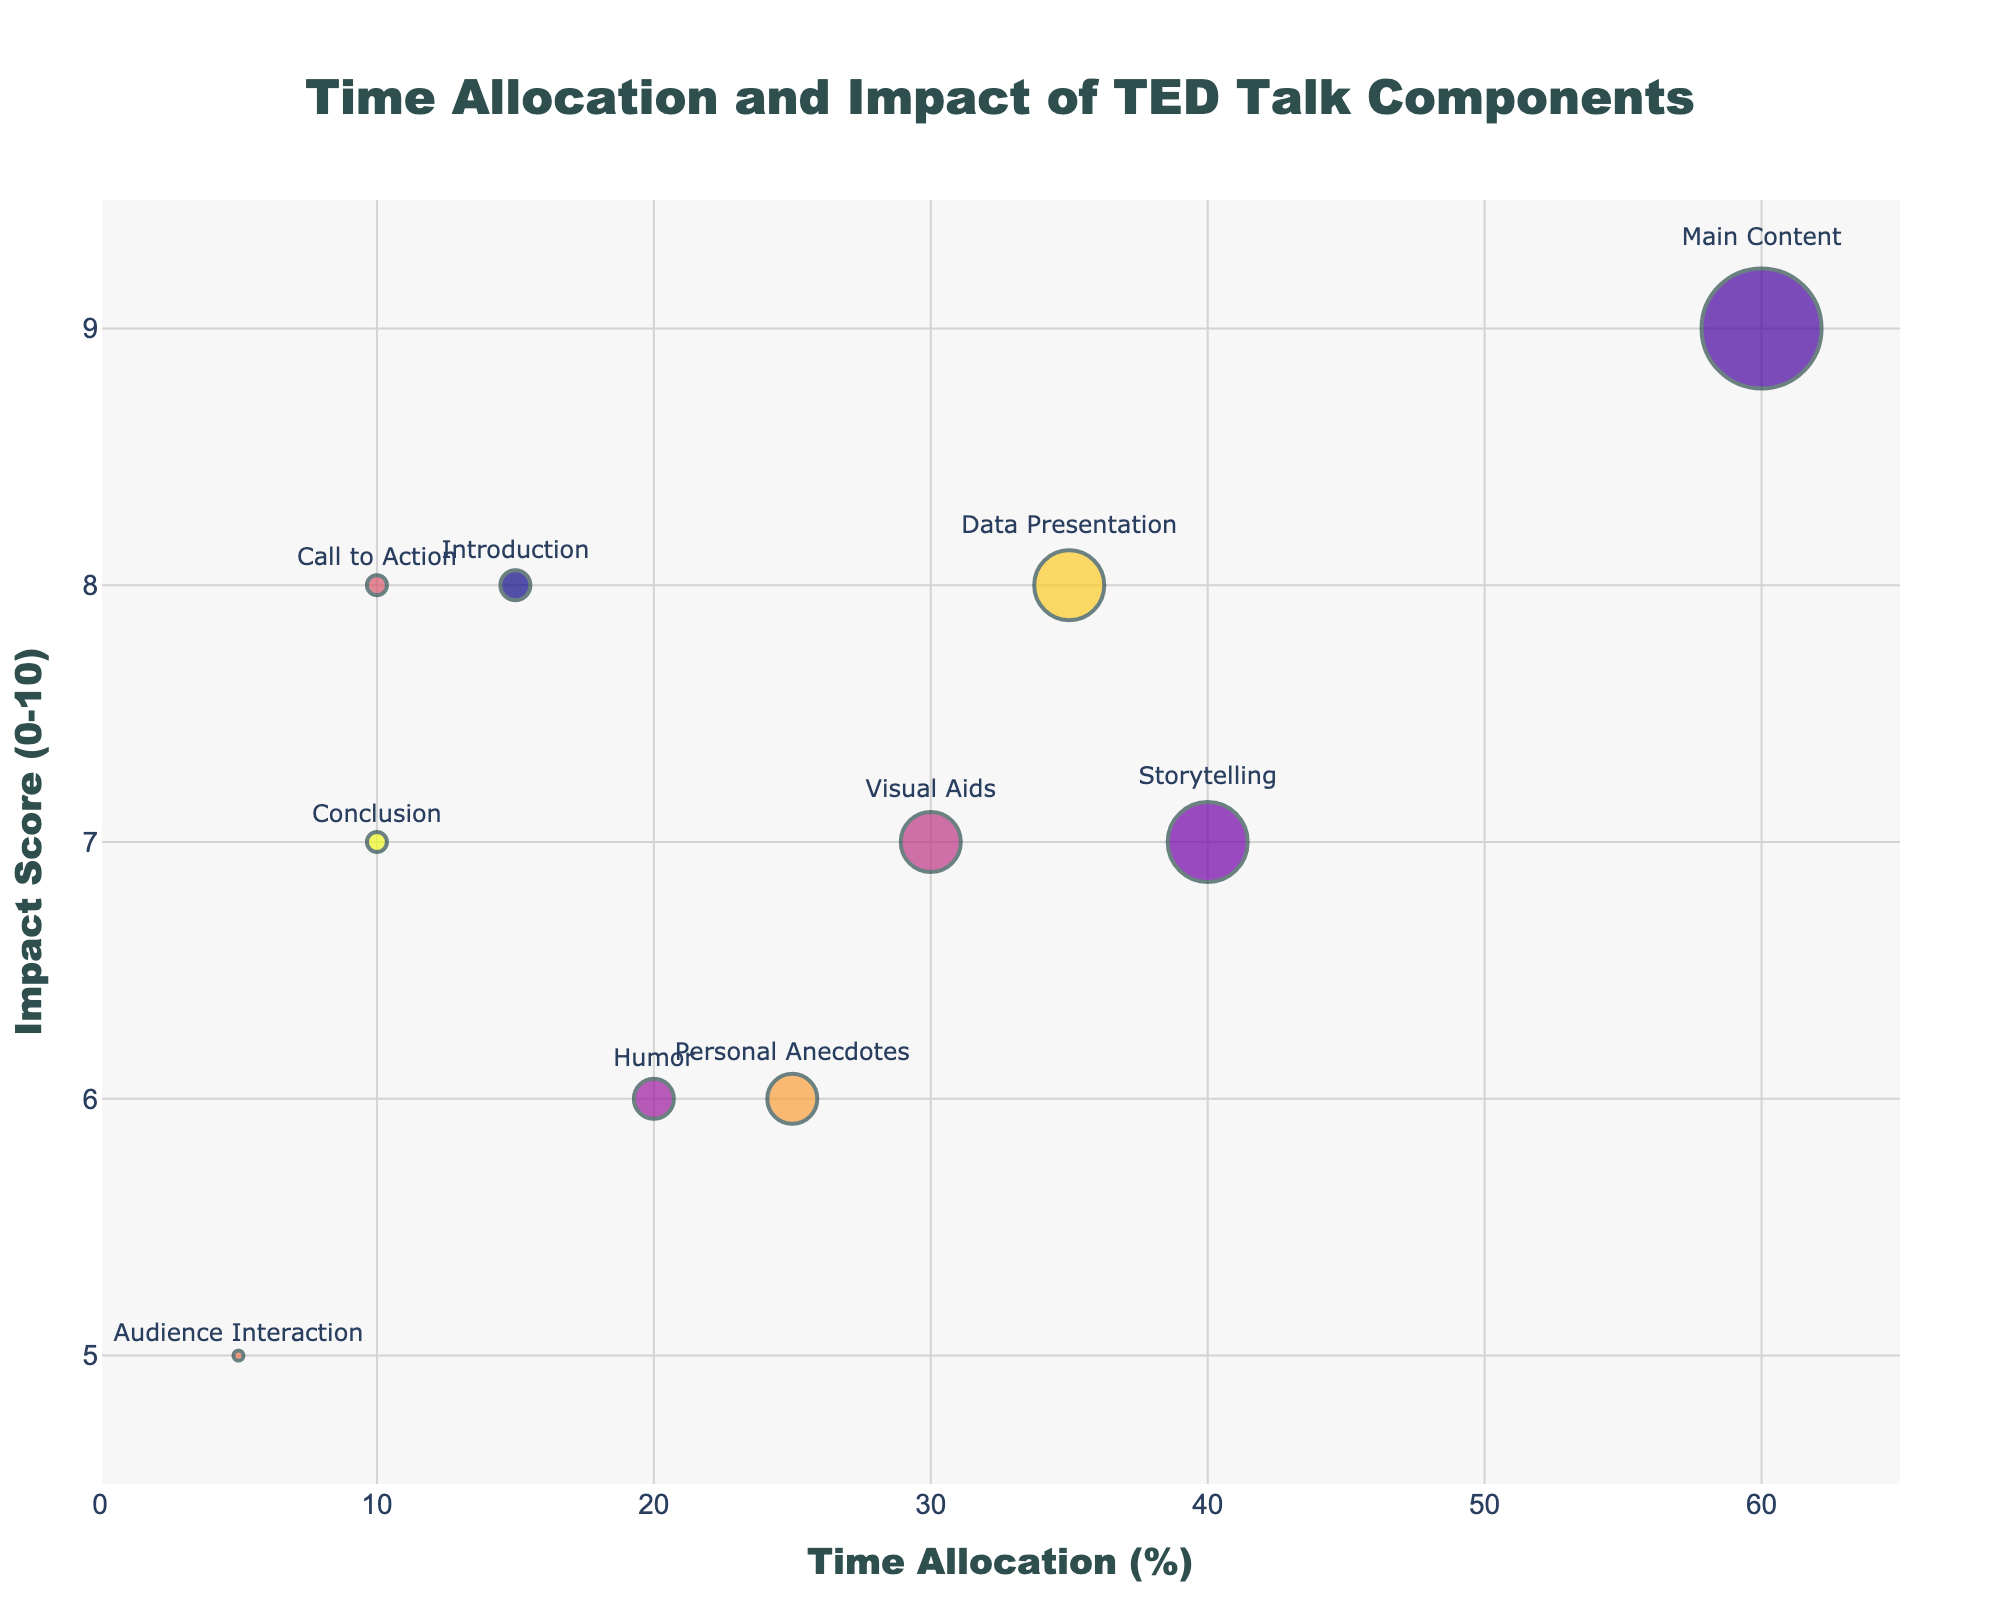How many components have a time allocation of 10%? The figure shows the time allocation percentages for all components. By examining the x-axis values, we see two components (Call to Action and Conclusion) each have 10% allocated.
Answer: 2 Which component has the highest impact score? By comparing the y-axis values for all components, the Main Content component has the highest impact score of 9.
Answer: Main Content What's the difference in time allocation between Introduction and Storytelling components? The time allocation of Introduction is 15%, and Storytelling is 40%. Subtracting 15 from 40 gives the difference of 25%.
Answer: 25% How many components have an impact score above 7? By inspecting the y-axis values, we find that five components (Introduction, Main Content, Call to Action, Data Presentation, and Conclusion) have an impact score above 7.
Answer: 5 Which two components have the closest time allocation? Comparing the percentages on the x-axis, Humor and Call to Action have the closest time allocations at 20% and 10%, respectively, with a difference of 10%.
Answer: Humor and Call to Action Calculate the total time allocation for Visual Aids, Humor, and Personal Anecdotes. Adding the percentages for these components: 30% (Visual Aids) + 20% (Humor) + 25% (Personal Anecdotes) = 75%.
Answer: 75% Which component has the same impact score as Visual Aids? Both Visual Aids and Storytelling have an impact score of 7, as given by their y-axis positions.
Answer: Storytelling What is the average impact score of all the components? Summing the impact scores: 8+9+7+6+7+8+5+6+8+7 = 71. Dividing by the number of components (10), the average is 71/10 = 7.1.
Answer: 7.1 Identify the smallest bubble size and the component it represents. The smallest bubble corresponds to Audience Interaction with a time allocation of 5%, which is the smallest size on the x-axis.
Answer: Audience Interaction, 5% Which component has both the highest percentage and impact score? Main Content has the highest percentage of 60% and the highest impact score of 9.
Answer: Main Content 